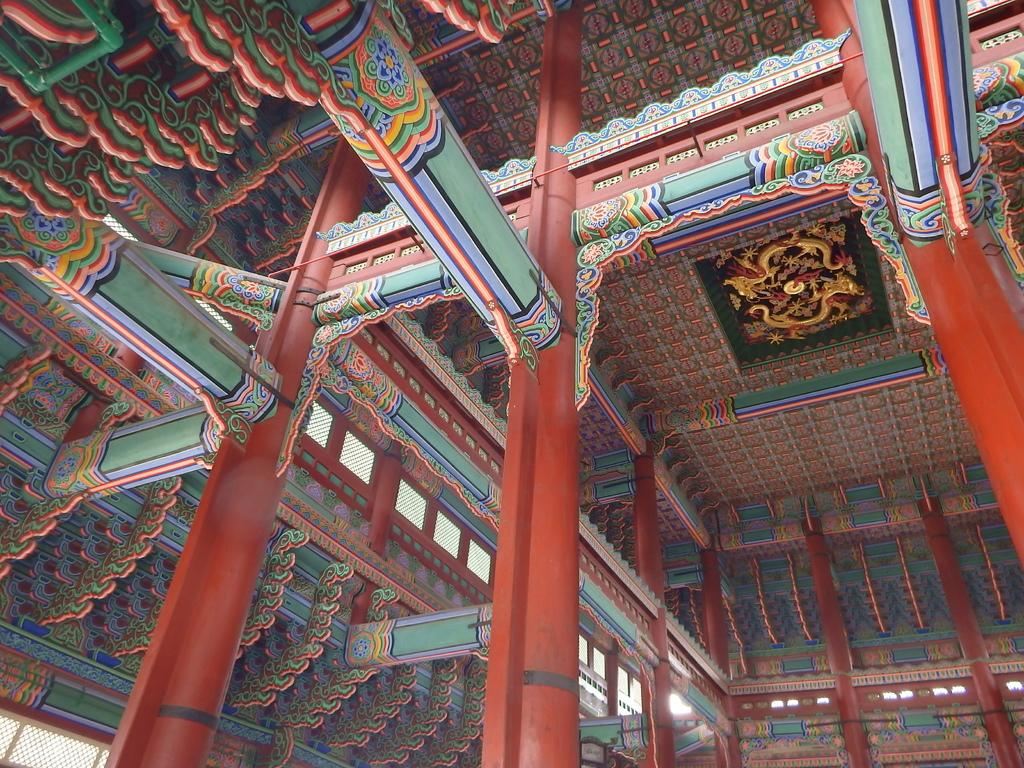What type of view does the image provide? The image provides an inside view of a building. What can be seen on the ceiling in the image? There are designs on the ceiling in the image. What type of lamp is hanging from the ceiling in the image? There is no lamp visible in the image; it only shows designs on the ceiling. Is there a jail cell present in the image? There is no indication of a jail cell or any related elements in the image. 